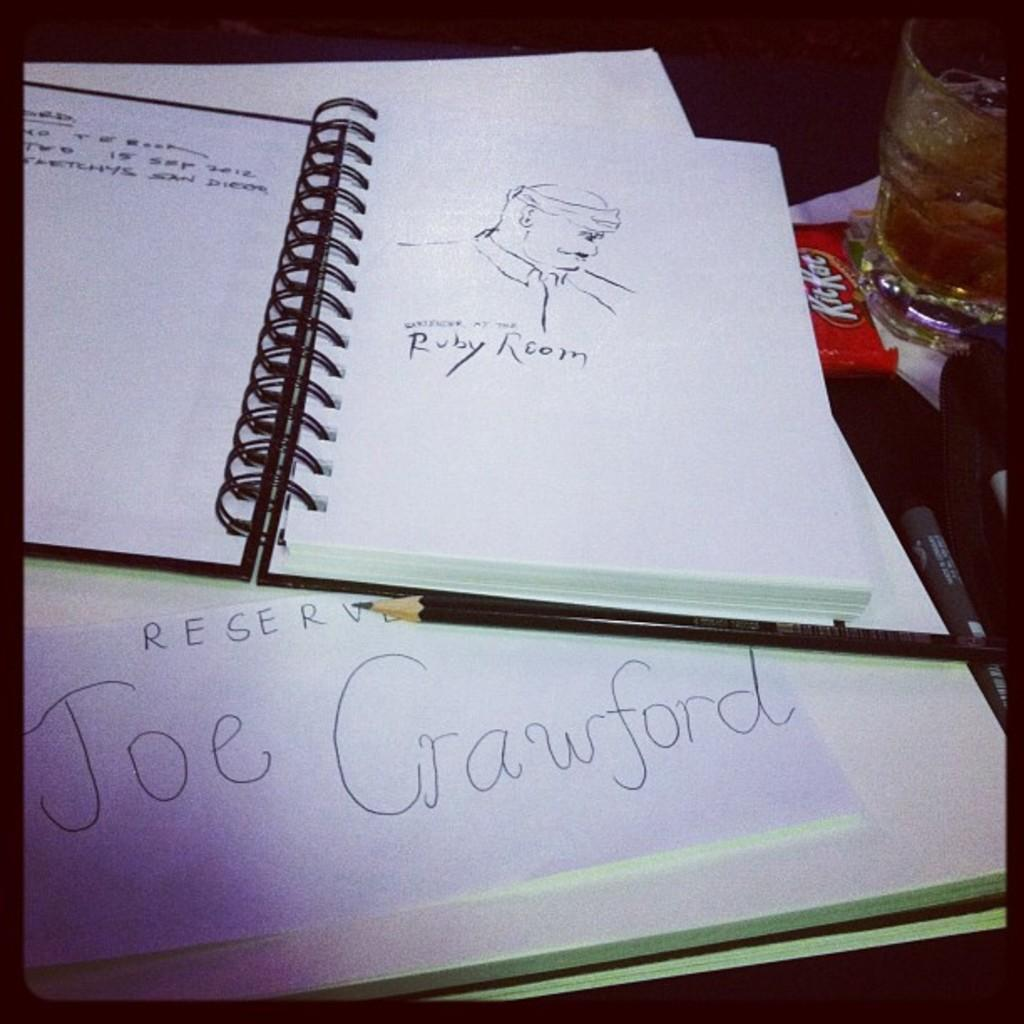<image>
Write a terse but informative summary of the picture. a notebook with a drawing of a face over a sign with the name Joe Crawford written on it 